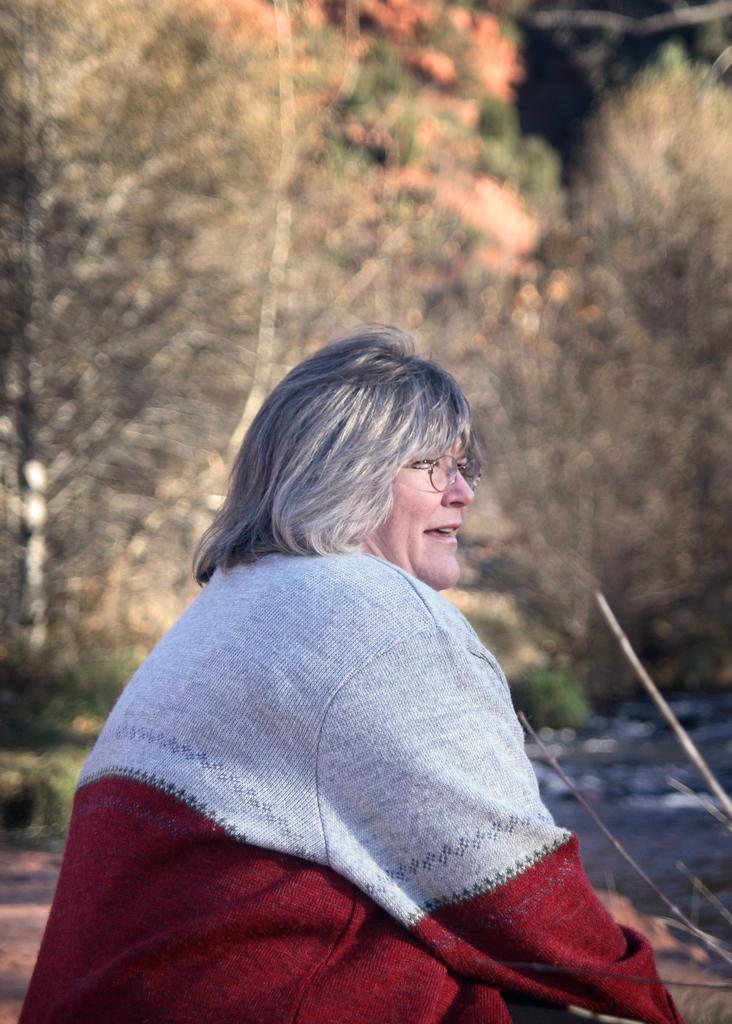What can be seen on the person in the image? There is a person with spectacles in the image. What is visible in the image besides the person? Water is visible in the image. What can be seen in the background of the image? There are trees in the background of the image. What type of iron is being used by the writer in the image? There is no writer or iron present in the image. 